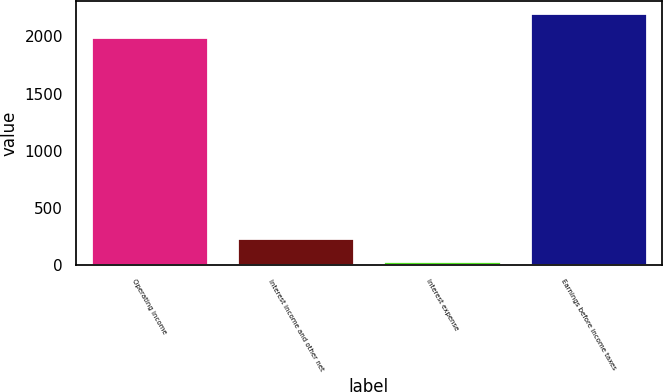Convert chart to OTSL. <chart><loc_0><loc_0><loc_500><loc_500><bar_chart><fcel>Operating income<fcel>Interest income and other net<fcel>Interest expense<fcel>Earnings before income taxes<nl><fcel>1997.4<fcel>235.34<fcel>32.7<fcel>2200.04<nl></chart> 